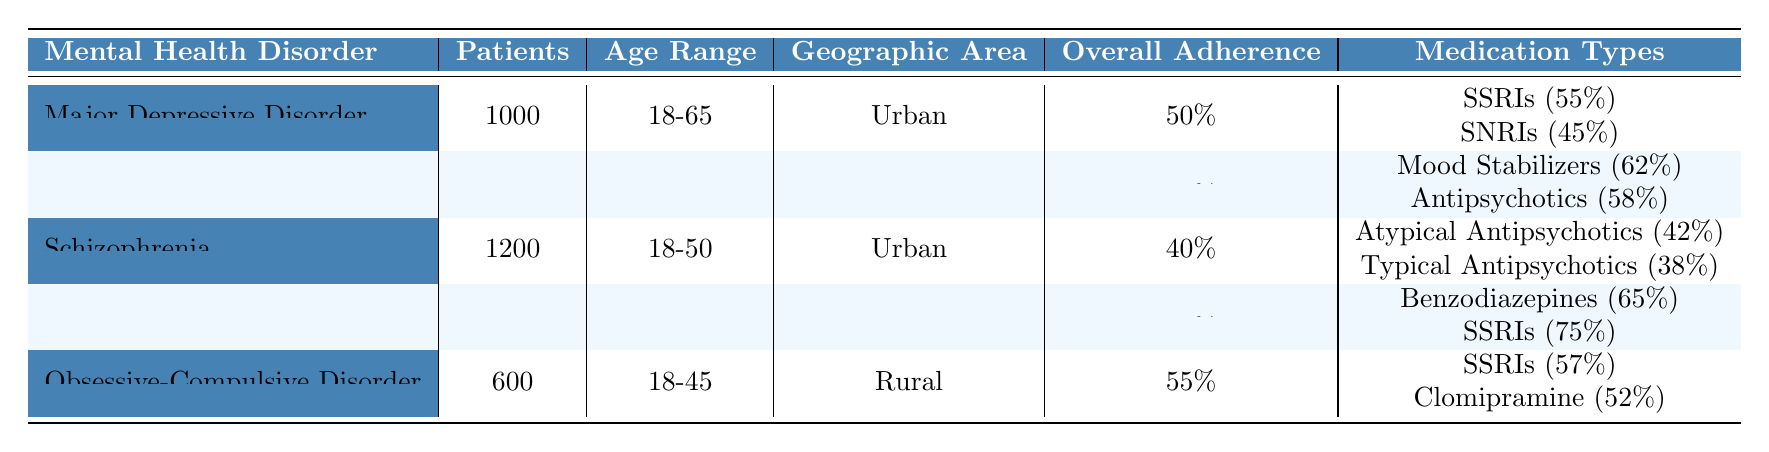What is the overall medication adherence rate for Generalized Anxiety Disorder? The table shows that the overall adherence rate for Generalized Anxiety Disorder is listed clearly under the 'Overall Adherence' column, which states 70%.
Answer: 70% How many patients are there for Bipolar Disorder? The number of patients for Bipolar Disorder is provided directly in the 'Patients' column, indicating there are 800 patients.
Answer: 800 Which mental health disorder has the lowest overall medication adherence rate? By comparing the 'Overall Adherence' percentages from each disorder, Schizophrenia has the lowest rate at 40%.
Answer: Schizophrenia What is the adherence rate for SSRIs in Major Depressive Disorder? Under the 'Medication Types' section for Major Depressive Disorder, SSRIs have an adherence rate of 55%.
Answer: 55% If you combine the populations of Major Depressive Disorder and Obsessive-Compulsive Disorder, how many total patients are there? The table shows 1000 patients for Major Depressive Disorder and 600 for Obsessive-Compulsive Disorder. Adding these gives 1000 + 600 = 1600 patients total.
Answer: 1600 Is the adherence rate for Mood Stabilizers higher or lower than that for Antipsychotics in Bipolar Disorder? For Bipolar Disorder, Mood Stabilizers have an adherence rate of 62%, while Antipsychotics have 58%. Since 62% is greater than 58%, Mood Stabilizers have a higher adherence rate.
Answer: Higher What is the age range of patients with Obsessive-Compulsive Disorder? The 'Age Range' column for Obsessive-Compulsive Disorder specifies that the range is 18-45 years.
Answer: 18-45 Calculate the average medication adherence rate for all disorders listed in the table. The adherence rates to consider are: 50%, 60%, 40%, 70%, and 55%. Summing these gives 275%. Dividing by the number of disorders (5), the average is 275% / 5 = 55%.
Answer: 55% Is the overall adherence rate for patients in Urban areas generally higher than for those in Rural areas? The average adherence rates for Urban areas (50%, 40%, 70%) sum to 160% for 3 disorders, which is an average of 53.3%. The Rural area has one disorder with an adherence rate of 55%. Since 53.3% is less than 55%, Urban areas do not have a higher overall adherence rate.
Answer: No Which medication type for Obsessive-Compulsive Disorder has the higher adherence rate, SSRIs or Clomipramine? The adherence rates for SSRIs and Clomipramine under Obsessive-Compulsive Disorder are 57% and 52%, respectively. Since 57% is greater than 52%, SSRIs have a higher adherence rate.
Answer: SSRIs How many patients in Schizophrenia have adherence rates that are below the overall average? The overall average adherence rate calculated earlier is 55%. In Schizophrenia, the adherence rates for Atypical Antipsychotics (42%) and Typical Antipsychotics (38%) are both below 55%. Therefore, the total number of patients below the average is 1200 (the total number of patients in Schizophrenia).
Answer: 1200 